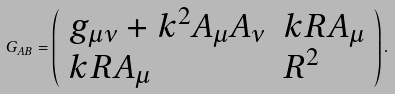Convert formula to latex. <formula><loc_0><loc_0><loc_500><loc_500>G _ { A B } = \left ( \begin{array} { l l } g _ { \mu \nu } + k ^ { 2 } A _ { \mu } A _ { \nu } & k R A _ { \mu } \\ k R A _ { \mu } & R ^ { 2 } \\ \end{array} \right ) .</formula> 